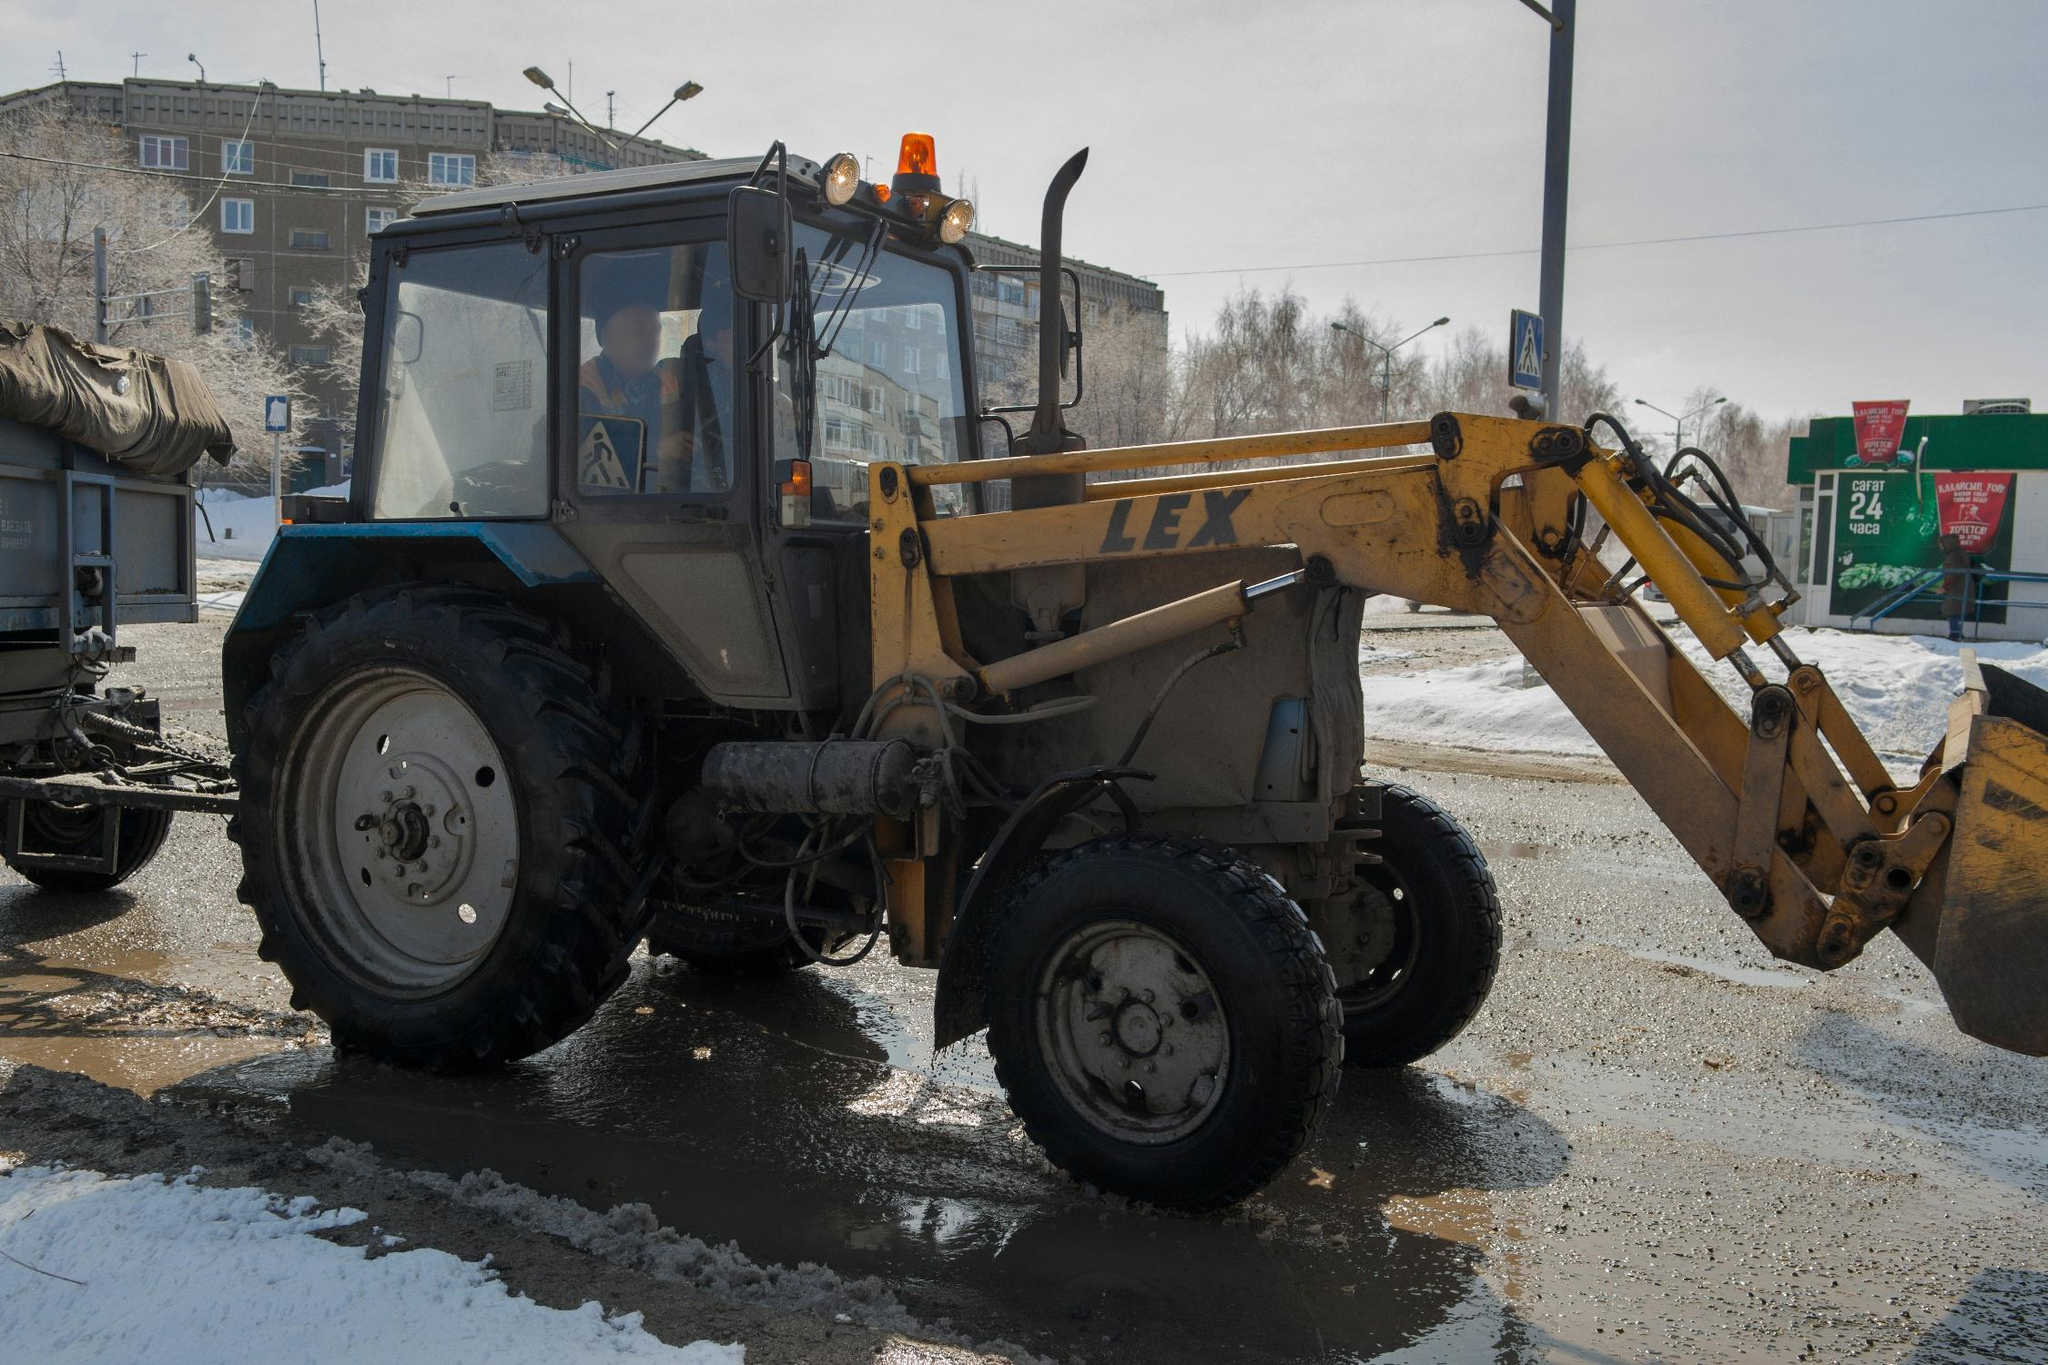Can you elaborate on the elements of the picture provided?
 In the midst of a snowy street, a yellow and black tractor with a front loader stands out. The tractor, emblazoned with a white "LEX" logo on its side, is parked on the right, facing towards the left of the frame. The front loader, extended and resting on the snow-covered ground, seems ready for action. 

Inside the tractor, a person can be seen in the driver's seat, perhaps preparing for the task at hand. The tractor's tire tracks are imprinted in the snow, hinting at its recent movement.

In the background, a building, a street lamp, and a green billboard add to the urban landscape. Despite the cold and snowy conditions, the scene is a testament to the resilience of daily life and work. 